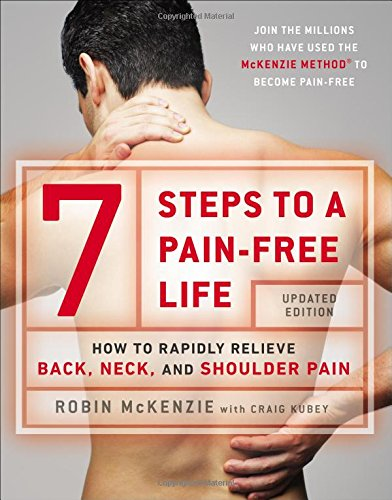What is the genre of this book? This book falls under the 'Health, Fitness & Dieting' genre, specifically targeting readers looking to manage and recover from physical pain through established therapeutic exercises. 